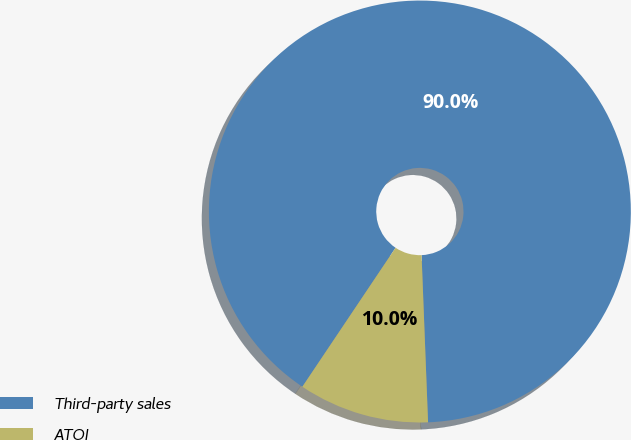Convert chart to OTSL. <chart><loc_0><loc_0><loc_500><loc_500><pie_chart><fcel>Third-party sales<fcel>ATOI<nl><fcel>89.98%<fcel>10.02%<nl></chart> 